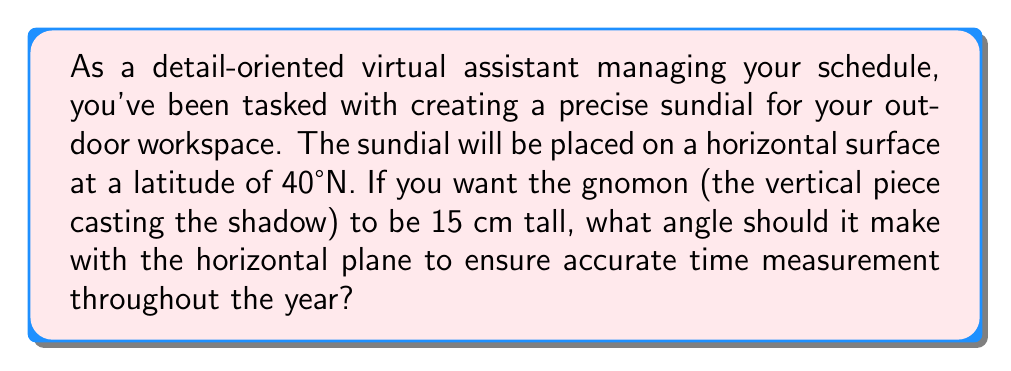Can you answer this question? To create an accurate sundial, the gnomon must be parallel to the Earth's axis of rotation. This means it should point towards the celestial pole, which is at an angle equal to the observer's latitude above the horizon.

Let's approach this step-by-step:

1. The angle between the gnomon and the horizontal plane should be equal to the latitude of the location.

2. Given information:
   - Latitude: 40°N
   - Gnomon height: 15 cm

3. The angle we're looking for is 40°, but let's verify this using trigonometry.

4. In a right-angled triangle formed by the gnomon and the horizontal plane:
   
   $\tan(\theta) = \frac{\text{opposite}}{\text{adjacent}} = \frac{\text{gnomon height}}{\text{base length}}$

5. We know the gnomon height (15 cm) and the angle (40°), so we can calculate the base length:

   $\text{base length} = \frac{\text{gnomon height}}{\tan(40°)}$

6. Using a calculator:
   
   $\text{base length} = \frac{15}{\tan(40°)} \approx 17.86 \text{ cm}$

7. We can verify our angle using the arctangent function:

   $\theta = \arctan(\frac{15}{17.86}) \approx 40°$

[asy]
import geometry;

size(200);
pair A=(0,0), B=(17.86,0), C=(0,15);
draw(A--B--C--A);
draw(A--(17.86,2), arrow=Arrow(TeXHead));
draw((1,0)--(1,1)--(2,1), L=Label("40°", position=MidPoint));
label("15 cm", C, W);
label("17.86 cm", (8.93,0), S);
[/asy]

This confirms that the angle of 40° is correct for creating an accurate sundial at this latitude.
Answer: The gnomon should make an angle of 40° with the horizontal plane. 